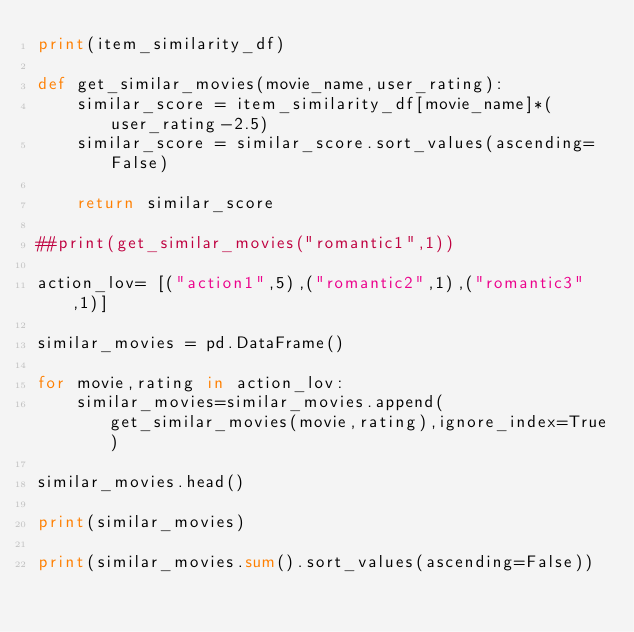Convert code to text. <code><loc_0><loc_0><loc_500><loc_500><_Python_>print(item_similarity_df)

def get_similar_movies(movie_name,user_rating):
    similar_score = item_similarity_df[movie_name]*(user_rating-2.5)
    similar_score = similar_score.sort_values(ascending=False)

    return similar_score

##print(get_similar_movies("romantic1",1))

action_lov= [("action1",5),("romantic2",1),("romantic3",1)]

similar_movies = pd.DataFrame()

for movie,rating in action_lov:
    similar_movies=similar_movies.append(get_similar_movies(movie,rating),ignore_index=True)

similar_movies.head()

print(similar_movies)

print(similar_movies.sum().sort_values(ascending=False))</code> 